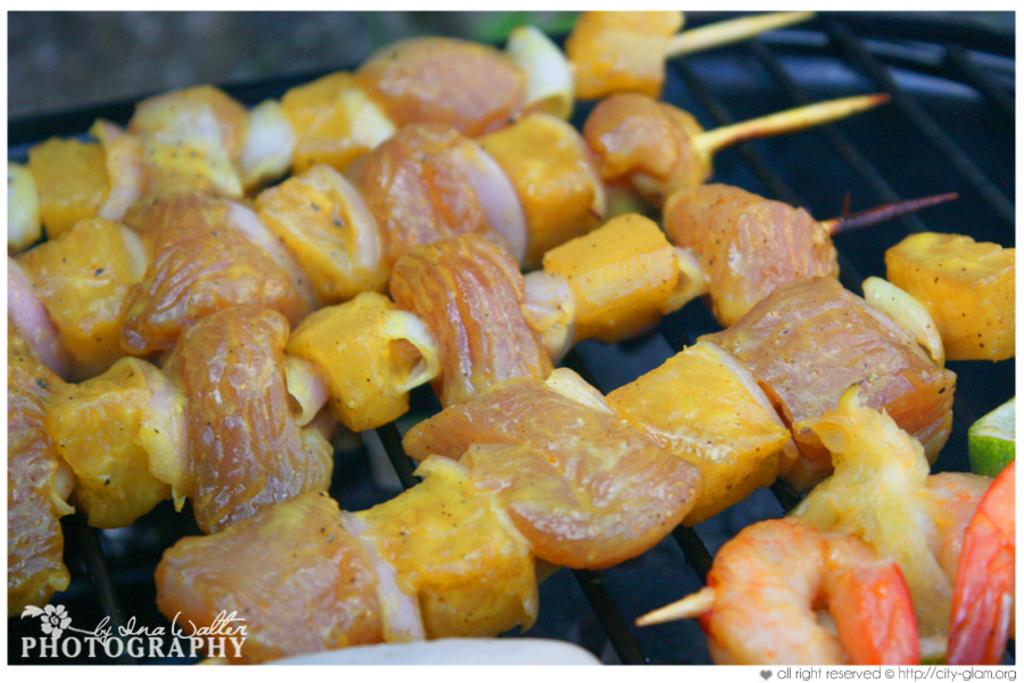What is the main feature of the image? There is a logo in the image. What is happening with the food in the image? There are meat items and seafood items on a grill in the image. Where might this image have been taken? The image may have been taken in a restaurant. What type of feeling can be seen on the faces of the snakes in the image? There are no snakes present in the image, so it is not possible to determine their feelings. 